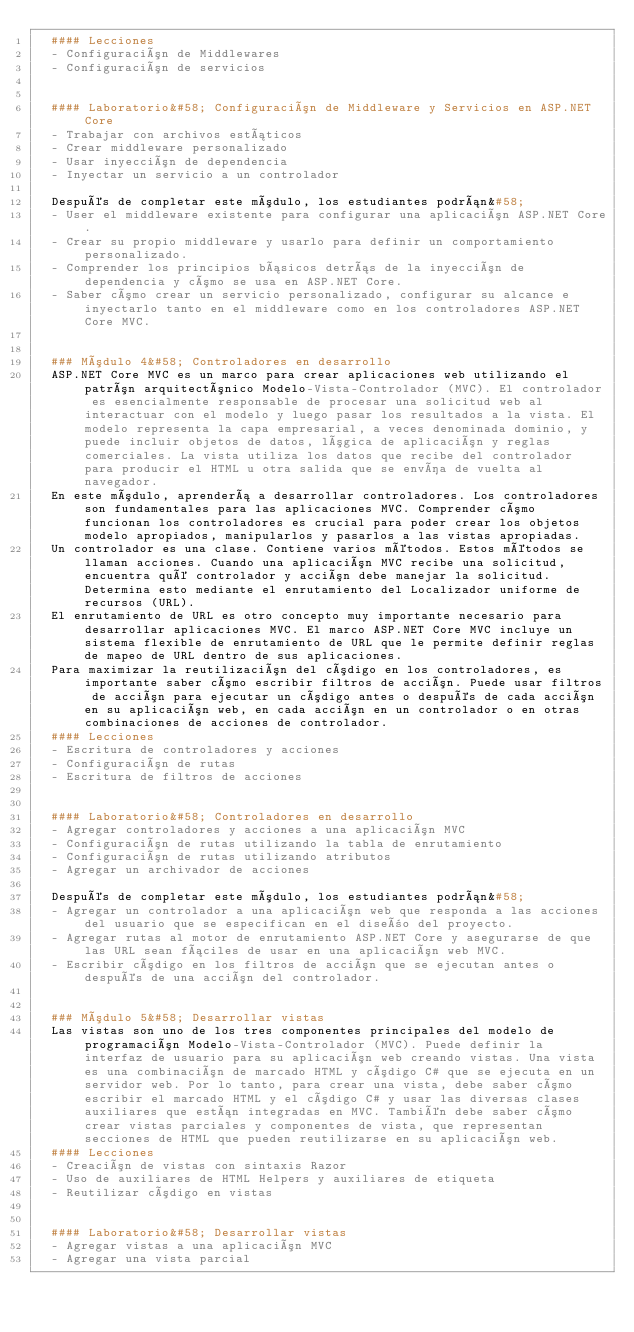<code> <loc_0><loc_0><loc_500><loc_500><_YAML_>  #### Lecciones
  - Configuración de Middlewares
  - Configuración de servicios


  #### Laboratorio&#58; Configuración de Middleware y Servicios en ASP.NET Core
  - Trabajar con archivos estáticos
  - Crear middleware personalizado
  - Usar inyección de dependencia
  - Inyectar un servicio a un controlador

  Después de completar este módulo, los estudiantes podrán&#58;
  - User el middleware existente para configurar una aplicación ASP.NET Core.
  - Crear su propio middleware y usarlo para definir un comportamiento personalizado.
  - Comprender los principios básicos detrás de la inyección de dependencia y cómo se usa en ASP.NET Core.
  - Saber cómo crear un servicio personalizado, configurar su alcance e inyectarlo tanto en el middleware como en los controladores ASP.NET Core MVC.


  ### Módulo 4&#58; Controladores en desarrollo
  ASP.NET Core MVC es un marco para crear aplicaciones web utilizando el patrón arquitectónico Modelo-Vista-Controlador (MVC). El controlador es esencialmente responsable de procesar una solicitud web al interactuar con el modelo y luego pasar los resultados a la vista. El modelo representa la capa empresarial, a veces denominada dominio, y puede incluir objetos de datos, lógica de aplicación y reglas comerciales. La vista utiliza los datos que recibe del controlador para producir el HTML u otra salida que se envía de vuelta al navegador.
  En este módulo, aprenderá a desarrollar controladores. Los controladores son fundamentales para las aplicaciones MVC. Comprender cómo funcionan los controladores es crucial para poder crear los objetos modelo apropiados, manipularlos y pasarlos a las vistas apropiadas.
  Un controlador es una clase. Contiene varios métodos. Estos métodos se llaman acciones. Cuando una aplicación MVC recibe una solicitud, encuentra qué controlador y acción debe manejar la solicitud. Determina esto mediante el enrutamiento del Localizador uniforme de recursos (URL).
  El enrutamiento de URL es otro concepto muy importante necesario para desarrollar aplicaciones MVC. El marco ASP.NET Core MVC incluye un sistema flexible de enrutamiento de URL que le permite definir reglas de mapeo de URL dentro de sus aplicaciones.
  Para maximizar la reutilización del código en los controladores, es importante saber cómo escribir filtros de acción. Puede usar filtros de acción para ejecutar un código antes o después de cada acción en su aplicación web, en cada acción en un controlador o en otras combinaciones de acciones de controlador.
  #### Lecciones
  - Escritura de controladores y acciones
  - Configuración de rutas
  - Escritura de filtros de acciones


  #### Laboratorio&#58; Controladores en desarrollo
  - Agregar controladores y acciones a una aplicación MVC
  - Configuración de rutas utilizando la tabla de enrutamiento
  - Configuración de rutas utilizando atributos
  - Agregar un archivador de acciones

  Después de completar este módulo, los estudiantes podrán&#58;
  - Agregar un controlador a una aplicación web que responda a las acciones del usuario que se especifican en el diseño del proyecto.
  - Agregar rutas al motor de enrutamiento ASP.NET Core y asegurarse de que las URL sean fáciles de usar en una aplicación web MVC.
  - Escribir código en los filtros de acción que se ejecutan antes o después de una acción del controlador.


  ### Módulo 5&#58; Desarrollar vistas
  Las vistas son uno de los tres componentes principales del modelo de programación Modelo-Vista-Controlador (MVC). Puede definir la interfaz de usuario para su aplicación web creando vistas. Una vista es una combinación de marcado HTML y código C# que se ejecuta en un servidor web. Por lo tanto, para crear una vista, debe saber cómo escribir el marcado HTML y el código C# y usar las diversas clases auxiliares que están integradas en MVC. También debe saber cómo crear vistas parciales y componentes de vista, que representan secciones de HTML que pueden reutilizarse en su aplicación web.
  #### Lecciones
  - Creación de vistas con sintaxis Razor
  - Uso de auxiliares de HTML Helpers y auxiliares de etiqueta
  - Reutilizar código en vistas


  #### Laboratorio&#58; Desarrollar vistas
  - Agregar vistas a una aplicación MVC
  - Agregar una vista parcial</code> 